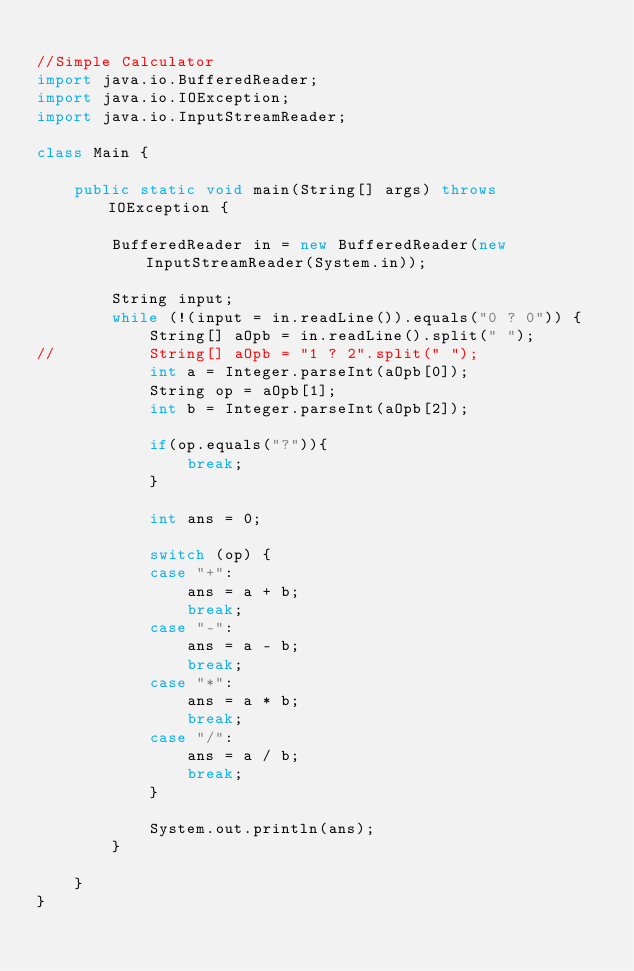<code> <loc_0><loc_0><loc_500><loc_500><_Java_>
//Simple Calculator
import java.io.BufferedReader;
import java.io.IOException;
import java.io.InputStreamReader;

class Main {

	public static void main(String[] args) throws IOException {

		BufferedReader in = new BufferedReader(new InputStreamReader(System.in));

		String input;
		while (!(input = in.readLine()).equals("0 ? 0")) {
			String[] aOpb = in.readLine().split(" ");
//			String[] aOpb = "1 ? 2".split(" ");
			int a = Integer.parseInt(aOpb[0]);
			String op = aOpb[1];
			int b = Integer.parseInt(aOpb[2]);

			if(op.equals("?")){
				break;
			}
			
			int ans = 0;

			switch (op) {
			case "+":
				ans = a + b;
				break;
			case "-":
				ans = a - b;
				break;
			case "*":
				ans = a * b;
				break;
			case "/":
				ans = a / b;
				break;
			}

			System.out.println(ans);
		}

	}
}</code> 